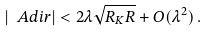<formula> <loc_0><loc_0><loc_500><loc_500>| \ A d i r | < 2 \lambda \sqrt { R _ { K } R } + O ( \lambda ^ { 2 } ) \, .</formula> 